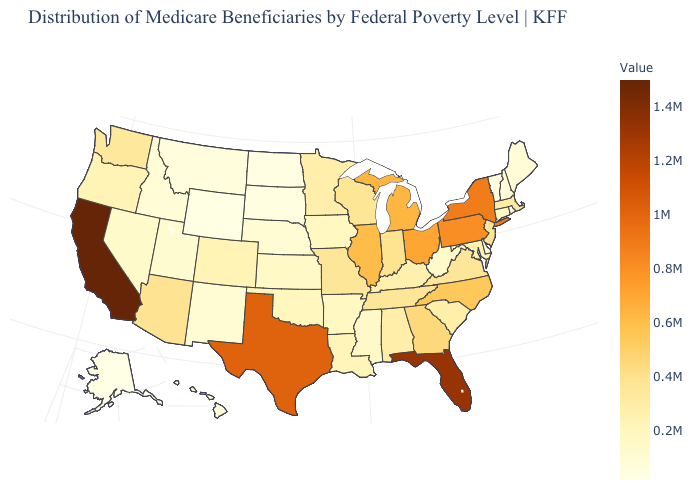Does Idaho have the highest value in the USA?
Write a very short answer. No. Among the states that border Utah , does Colorado have the lowest value?
Short answer required. No. Does California have the highest value in the USA?
Answer briefly. Yes. Is the legend a continuous bar?
Write a very short answer. Yes. 